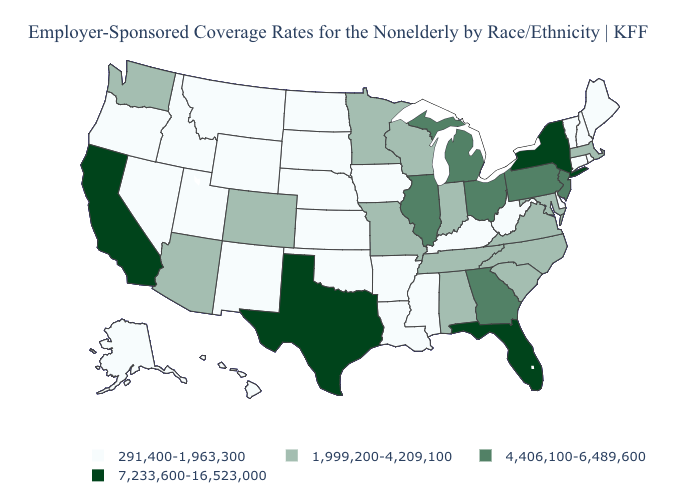How many symbols are there in the legend?
Answer briefly. 4. Does Utah have the lowest value in the USA?
Be succinct. Yes. What is the value of Minnesota?
Keep it brief. 1,999,200-4,209,100. Does the first symbol in the legend represent the smallest category?
Answer briefly. Yes. Is the legend a continuous bar?
Give a very brief answer. No. Does North Dakota have a lower value than West Virginia?
Write a very short answer. No. What is the value of Mississippi?
Be succinct. 291,400-1,963,300. Which states have the lowest value in the MidWest?
Give a very brief answer. Iowa, Kansas, Nebraska, North Dakota, South Dakota. Among the states that border New York , does Vermont have the lowest value?
Short answer required. Yes. Name the states that have a value in the range 7,233,600-16,523,000?
Answer briefly. California, Florida, New York, Texas. Does the first symbol in the legend represent the smallest category?
Answer briefly. Yes. Name the states that have a value in the range 291,400-1,963,300?
Write a very short answer. Alaska, Arkansas, Connecticut, Delaware, Hawaii, Idaho, Iowa, Kansas, Kentucky, Louisiana, Maine, Mississippi, Montana, Nebraska, Nevada, New Hampshire, New Mexico, North Dakota, Oklahoma, Oregon, Rhode Island, South Dakota, Utah, Vermont, West Virginia, Wyoming. What is the value of Ohio?
Write a very short answer. 4,406,100-6,489,600. What is the value of Texas?
Answer briefly. 7,233,600-16,523,000. Does Kentucky have the highest value in the USA?
Short answer required. No. 